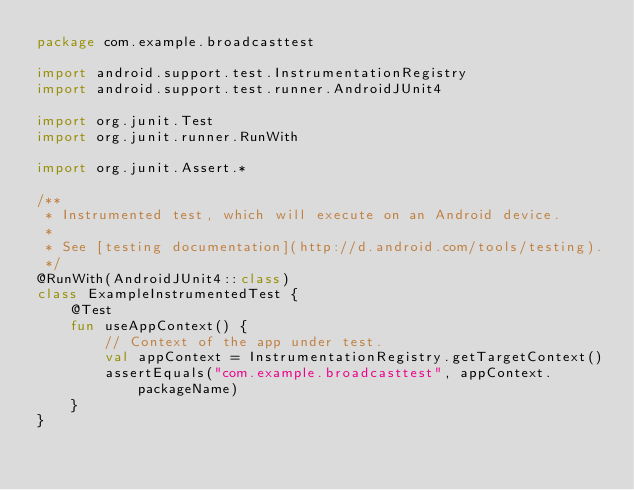Convert code to text. <code><loc_0><loc_0><loc_500><loc_500><_Kotlin_>package com.example.broadcasttest

import android.support.test.InstrumentationRegistry
import android.support.test.runner.AndroidJUnit4

import org.junit.Test
import org.junit.runner.RunWith

import org.junit.Assert.*

/**
 * Instrumented test, which will execute on an Android device.
 *
 * See [testing documentation](http://d.android.com/tools/testing).
 */
@RunWith(AndroidJUnit4::class)
class ExampleInstrumentedTest {
    @Test
    fun useAppContext() {
        // Context of the app under test.
        val appContext = InstrumentationRegistry.getTargetContext()
        assertEquals("com.example.broadcasttest", appContext.packageName)
    }
}
</code> 